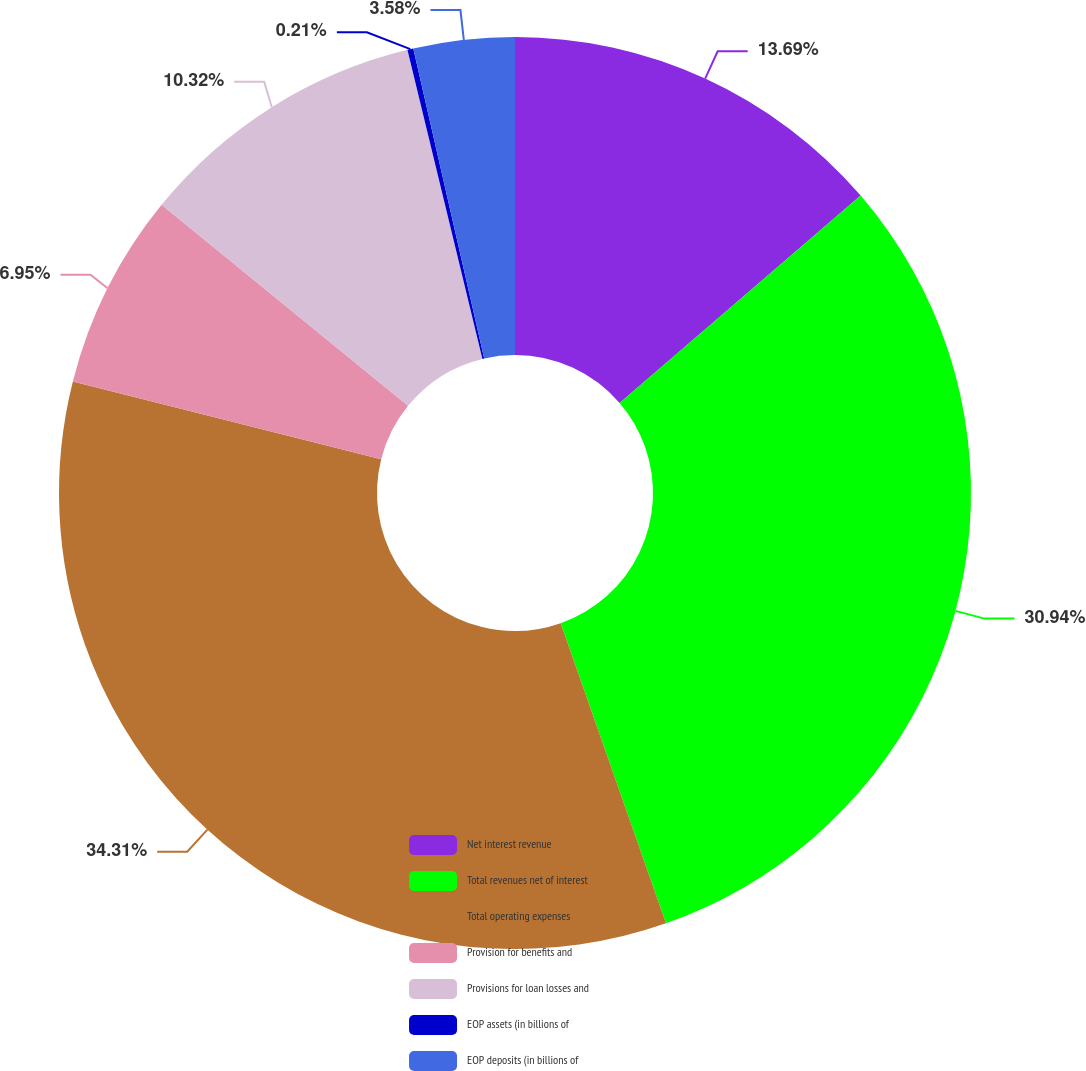Convert chart. <chart><loc_0><loc_0><loc_500><loc_500><pie_chart><fcel>Net interest revenue<fcel>Total revenues net of interest<fcel>Total operating expenses<fcel>Provision for benefits and<fcel>Provisions for loan losses and<fcel>EOP assets (in billions of<fcel>EOP deposits (in billions of<nl><fcel>13.69%<fcel>30.93%<fcel>34.3%<fcel>6.95%<fcel>10.32%<fcel>0.21%<fcel>3.58%<nl></chart> 